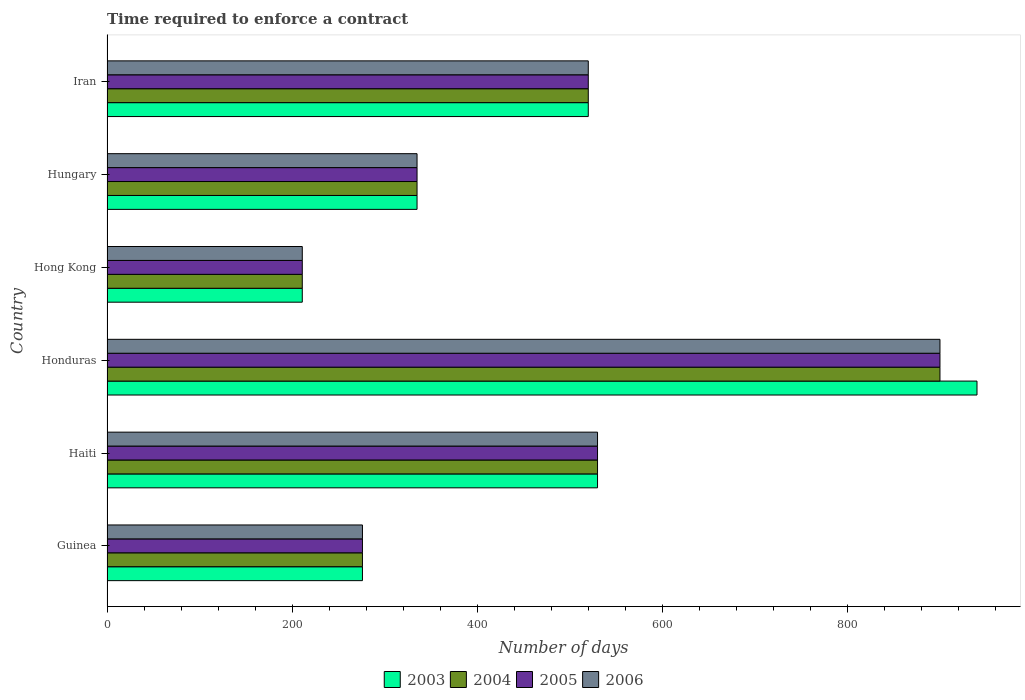How many different coloured bars are there?
Keep it short and to the point. 4. How many groups of bars are there?
Offer a very short reply. 6. Are the number of bars per tick equal to the number of legend labels?
Keep it short and to the point. Yes. What is the label of the 4th group of bars from the top?
Ensure brevity in your answer.  Honduras. In how many cases, is the number of bars for a given country not equal to the number of legend labels?
Keep it short and to the point. 0. What is the number of days required to enforce a contract in 2004 in Guinea?
Offer a very short reply. 276. Across all countries, what is the maximum number of days required to enforce a contract in 2006?
Keep it short and to the point. 900. Across all countries, what is the minimum number of days required to enforce a contract in 2005?
Offer a very short reply. 211. In which country was the number of days required to enforce a contract in 2003 maximum?
Make the answer very short. Honduras. In which country was the number of days required to enforce a contract in 2004 minimum?
Make the answer very short. Hong Kong. What is the total number of days required to enforce a contract in 2005 in the graph?
Provide a short and direct response. 2772. What is the difference between the number of days required to enforce a contract in 2003 in Haiti and that in Honduras?
Provide a succinct answer. -410. What is the difference between the number of days required to enforce a contract in 2003 in Honduras and the number of days required to enforce a contract in 2005 in Hong Kong?
Your answer should be very brief. 729. What is the average number of days required to enforce a contract in 2004 per country?
Make the answer very short. 462. In how many countries, is the number of days required to enforce a contract in 2003 greater than 40 days?
Your answer should be very brief. 6. What is the ratio of the number of days required to enforce a contract in 2005 in Hong Kong to that in Hungary?
Provide a succinct answer. 0.63. Is the number of days required to enforce a contract in 2005 in Honduras less than that in Iran?
Your answer should be compact. No. What is the difference between the highest and the second highest number of days required to enforce a contract in 2005?
Make the answer very short. 370. What is the difference between the highest and the lowest number of days required to enforce a contract in 2006?
Your answer should be very brief. 689. In how many countries, is the number of days required to enforce a contract in 2004 greater than the average number of days required to enforce a contract in 2004 taken over all countries?
Ensure brevity in your answer.  3. Is the sum of the number of days required to enforce a contract in 2004 in Guinea and Honduras greater than the maximum number of days required to enforce a contract in 2005 across all countries?
Your response must be concise. Yes. Is it the case that in every country, the sum of the number of days required to enforce a contract in 2006 and number of days required to enforce a contract in 2003 is greater than the sum of number of days required to enforce a contract in 2004 and number of days required to enforce a contract in 2005?
Ensure brevity in your answer.  No. Is it the case that in every country, the sum of the number of days required to enforce a contract in 2005 and number of days required to enforce a contract in 2004 is greater than the number of days required to enforce a contract in 2003?
Keep it short and to the point. Yes. Are all the bars in the graph horizontal?
Provide a succinct answer. Yes. Are the values on the major ticks of X-axis written in scientific E-notation?
Your answer should be very brief. No. How many legend labels are there?
Offer a very short reply. 4. How are the legend labels stacked?
Your answer should be compact. Horizontal. What is the title of the graph?
Ensure brevity in your answer.  Time required to enforce a contract. Does "1999" appear as one of the legend labels in the graph?
Ensure brevity in your answer.  No. What is the label or title of the X-axis?
Offer a terse response. Number of days. What is the Number of days of 2003 in Guinea?
Make the answer very short. 276. What is the Number of days in 2004 in Guinea?
Your answer should be very brief. 276. What is the Number of days of 2005 in Guinea?
Your response must be concise. 276. What is the Number of days of 2006 in Guinea?
Offer a very short reply. 276. What is the Number of days in 2003 in Haiti?
Your answer should be compact. 530. What is the Number of days of 2004 in Haiti?
Make the answer very short. 530. What is the Number of days of 2005 in Haiti?
Ensure brevity in your answer.  530. What is the Number of days of 2006 in Haiti?
Keep it short and to the point. 530. What is the Number of days of 2003 in Honduras?
Your response must be concise. 940. What is the Number of days of 2004 in Honduras?
Provide a succinct answer. 900. What is the Number of days in 2005 in Honduras?
Keep it short and to the point. 900. What is the Number of days in 2006 in Honduras?
Provide a succinct answer. 900. What is the Number of days in 2003 in Hong Kong?
Keep it short and to the point. 211. What is the Number of days of 2004 in Hong Kong?
Your response must be concise. 211. What is the Number of days of 2005 in Hong Kong?
Your response must be concise. 211. What is the Number of days of 2006 in Hong Kong?
Provide a short and direct response. 211. What is the Number of days of 2003 in Hungary?
Your response must be concise. 335. What is the Number of days of 2004 in Hungary?
Provide a short and direct response. 335. What is the Number of days in 2005 in Hungary?
Make the answer very short. 335. What is the Number of days in 2006 in Hungary?
Give a very brief answer. 335. What is the Number of days in 2003 in Iran?
Ensure brevity in your answer.  520. What is the Number of days of 2004 in Iran?
Keep it short and to the point. 520. What is the Number of days of 2005 in Iran?
Your answer should be compact. 520. What is the Number of days in 2006 in Iran?
Provide a short and direct response. 520. Across all countries, what is the maximum Number of days in 2003?
Your response must be concise. 940. Across all countries, what is the maximum Number of days of 2004?
Give a very brief answer. 900. Across all countries, what is the maximum Number of days of 2005?
Offer a very short reply. 900. Across all countries, what is the maximum Number of days of 2006?
Give a very brief answer. 900. Across all countries, what is the minimum Number of days in 2003?
Provide a succinct answer. 211. Across all countries, what is the minimum Number of days in 2004?
Ensure brevity in your answer.  211. Across all countries, what is the minimum Number of days of 2005?
Offer a terse response. 211. Across all countries, what is the minimum Number of days of 2006?
Offer a terse response. 211. What is the total Number of days in 2003 in the graph?
Make the answer very short. 2812. What is the total Number of days of 2004 in the graph?
Offer a terse response. 2772. What is the total Number of days of 2005 in the graph?
Your answer should be very brief. 2772. What is the total Number of days of 2006 in the graph?
Your answer should be very brief. 2772. What is the difference between the Number of days in 2003 in Guinea and that in Haiti?
Your answer should be very brief. -254. What is the difference between the Number of days in 2004 in Guinea and that in Haiti?
Offer a terse response. -254. What is the difference between the Number of days of 2005 in Guinea and that in Haiti?
Make the answer very short. -254. What is the difference between the Number of days in 2006 in Guinea and that in Haiti?
Keep it short and to the point. -254. What is the difference between the Number of days of 2003 in Guinea and that in Honduras?
Ensure brevity in your answer.  -664. What is the difference between the Number of days in 2004 in Guinea and that in Honduras?
Your answer should be compact. -624. What is the difference between the Number of days in 2005 in Guinea and that in Honduras?
Make the answer very short. -624. What is the difference between the Number of days in 2006 in Guinea and that in Honduras?
Keep it short and to the point. -624. What is the difference between the Number of days in 2003 in Guinea and that in Hong Kong?
Make the answer very short. 65. What is the difference between the Number of days of 2004 in Guinea and that in Hong Kong?
Offer a very short reply. 65. What is the difference between the Number of days of 2005 in Guinea and that in Hong Kong?
Ensure brevity in your answer.  65. What is the difference between the Number of days in 2006 in Guinea and that in Hong Kong?
Give a very brief answer. 65. What is the difference between the Number of days of 2003 in Guinea and that in Hungary?
Give a very brief answer. -59. What is the difference between the Number of days of 2004 in Guinea and that in Hungary?
Keep it short and to the point. -59. What is the difference between the Number of days of 2005 in Guinea and that in Hungary?
Your response must be concise. -59. What is the difference between the Number of days in 2006 in Guinea and that in Hungary?
Your response must be concise. -59. What is the difference between the Number of days of 2003 in Guinea and that in Iran?
Make the answer very short. -244. What is the difference between the Number of days of 2004 in Guinea and that in Iran?
Offer a terse response. -244. What is the difference between the Number of days in 2005 in Guinea and that in Iran?
Provide a succinct answer. -244. What is the difference between the Number of days of 2006 in Guinea and that in Iran?
Keep it short and to the point. -244. What is the difference between the Number of days of 2003 in Haiti and that in Honduras?
Your answer should be very brief. -410. What is the difference between the Number of days of 2004 in Haiti and that in Honduras?
Provide a succinct answer. -370. What is the difference between the Number of days in 2005 in Haiti and that in Honduras?
Provide a short and direct response. -370. What is the difference between the Number of days in 2006 in Haiti and that in Honduras?
Keep it short and to the point. -370. What is the difference between the Number of days of 2003 in Haiti and that in Hong Kong?
Your response must be concise. 319. What is the difference between the Number of days of 2004 in Haiti and that in Hong Kong?
Your response must be concise. 319. What is the difference between the Number of days of 2005 in Haiti and that in Hong Kong?
Your answer should be compact. 319. What is the difference between the Number of days in 2006 in Haiti and that in Hong Kong?
Ensure brevity in your answer.  319. What is the difference between the Number of days in 2003 in Haiti and that in Hungary?
Your response must be concise. 195. What is the difference between the Number of days in 2004 in Haiti and that in Hungary?
Provide a short and direct response. 195. What is the difference between the Number of days in 2005 in Haiti and that in Hungary?
Provide a short and direct response. 195. What is the difference between the Number of days in 2006 in Haiti and that in Hungary?
Your answer should be compact. 195. What is the difference between the Number of days in 2003 in Haiti and that in Iran?
Give a very brief answer. 10. What is the difference between the Number of days of 2004 in Haiti and that in Iran?
Offer a terse response. 10. What is the difference between the Number of days of 2003 in Honduras and that in Hong Kong?
Give a very brief answer. 729. What is the difference between the Number of days in 2004 in Honduras and that in Hong Kong?
Your response must be concise. 689. What is the difference between the Number of days of 2005 in Honduras and that in Hong Kong?
Give a very brief answer. 689. What is the difference between the Number of days of 2006 in Honduras and that in Hong Kong?
Offer a very short reply. 689. What is the difference between the Number of days of 2003 in Honduras and that in Hungary?
Ensure brevity in your answer.  605. What is the difference between the Number of days of 2004 in Honduras and that in Hungary?
Provide a short and direct response. 565. What is the difference between the Number of days of 2005 in Honduras and that in Hungary?
Give a very brief answer. 565. What is the difference between the Number of days of 2006 in Honduras and that in Hungary?
Ensure brevity in your answer.  565. What is the difference between the Number of days of 2003 in Honduras and that in Iran?
Ensure brevity in your answer.  420. What is the difference between the Number of days of 2004 in Honduras and that in Iran?
Offer a terse response. 380. What is the difference between the Number of days in 2005 in Honduras and that in Iran?
Keep it short and to the point. 380. What is the difference between the Number of days of 2006 in Honduras and that in Iran?
Keep it short and to the point. 380. What is the difference between the Number of days in 2003 in Hong Kong and that in Hungary?
Keep it short and to the point. -124. What is the difference between the Number of days of 2004 in Hong Kong and that in Hungary?
Make the answer very short. -124. What is the difference between the Number of days of 2005 in Hong Kong and that in Hungary?
Ensure brevity in your answer.  -124. What is the difference between the Number of days of 2006 in Hong Kong and that in Hungary?
Offer a terse response. -124. What is the difference between the Number of days of 2003 in Hong Kong and that in Iran?
Offer a terse response. -309. What is the difference between the Number of days in 2004 in Hong Kong and that in Iran?
Give a very brief answer. -309. What is the difference between the Number of days in 2005 in Hong Kong and that in Iran?
Your response must be concise. -309. What is the difference between the Number of days in 2006 in Hong Kong and that in Iran?
Your answer should be very brief. -309. What is the difference between the Number of days in 2003 in Hungary and that in Iran?
Your response must be concise. -185. What is the difference between the Number of days in 2004 in Hungary and that in Iran?
Provide a short and direct response. -185. What is the difference between the Number of days in 2005 in Hungary and that in Iran?
Your response must be concise. -185. What is the difference between the Number of days in 2006 in Hungary and that in Iran?
Your answer should be very brief. -185. What is the difference between the Number of days in 2003 in Guinea and the Number of days in 2004 in Haiti?
Offer a terse response. -254. What is the difference between the Number of days in 2003 in Guinea and the Number of days in 2005 in Haiti?
Your answer should be compact. -254. What is the difference between the Number of days in 2003 in Guinea and the Number of days in 2006 in Haiti?
Your response must be concise. -254. What is the difference between the Number of days in 2004 in Guinea and the Number of days in 2005 in Haiti?
Offer a terse response. -254. What is the difference between the Number of days of 2004 in Guinea and the Number of days of 2006 in Haiti?
Give a very brief answer. -254. What is the difference between the Number of days of 2005 in Guinea and the Number of days of 2006 in Haiti?
Provide a short and direct response. -254. What is the difference between the Number of days in 2003 in Guinea and the Number of days in 2004 in Honduras?
Keep it short and to the point. -624. What is the difference between the Number of days in 2003 in Guinea and the Number of days in 2005 in Honduras?
Ensure brevity in your answer.  -624. What is the difference between the Number of days in 2003 in Guinea and the Number of days in 2006 in Honduras?
Offer a terse response. -624. What is the difference between the Number of days of 2004 in Guinea and the Number of days of 2005 in Honduras?
Provide a short and direct response. -624. What is the difference between the Number of days in 2004 in Guinea and the Number of days in 2006 in Honduras?
Your answer should be very brief. -624. What is the difference between the Number of days in 2005 in Guinea and the Number of days in 2006 in Honduras?
Offer a terse response. -624. What is the difference between the Number of days in 2003 in Guinea and the Number of days in 2005 in Hong Kong?
Your answer should be compact. 65. What is the difference between the Number of days of 2004 in Guinea and the Number of days of 2005 in Hong Kong?
Provide a short and direct response. 65. What is the difference between the Number of days in 2004 in Guinea and the Number of days in 2006 in Hong Kong?
Ensure brevity in your answer.  65. What is the difference between the Number of days of 2005 in Guinea and the Number of days of 2006 in Hong Kong?
Offer a very short reply. 65. What is the difference between the Number of days of 2003 in Guinea and the Number of days of 2004 in Hungary?
Provide a succinct answer. -59. What is the difference between the Number of days in 2003 in Guinea and the Number of days in 2005 in Hungary?
Keep it short and to the point. -59. What is the difference between the Number of days of 2003 in Guinea and the Number of days of 2006 in Hungary?
Provide a succinct answer. -59. What is the difference between the Number of days of 2004 in Guinea and the Number of days of 2005 in Hungary?
Make the answer very short. -59. What is the difference between the Number of days in 2004 in Guinea and the Number of days in 2006 in Hungary?
Make the answer very short. -59. What is the difference between the Number of days of 2005 in Guinea and the Number of days of 2006 in Hungary?
Offer a terse response. -59. What is the difference between the Number of days in 2003 in Guinea and the Number of days in 2004 in Iran?
Ensure brevity in your answer.  -244. What is the difference between the Number of days of 2003 in Guinea and the Number of days of 2005 in Iran?
Your answer should be very brief. -244. What is the difference between the Number of days in 2003 in Guinea and the Number of days in 2006 in Iran?
Provide a succinct answer. -244. What is the difference between the Number of days in 2004 in Guinea and the Number of days in 2005 in Iran?
Provide a succinct answer. -244. What is the difference between the Number of days of 2004 in Guinea and the Number of days of 2006 in Iran?
Make the answer very short. -244. What is the difference between the Number of days in 2005 in Guinea and the Number of days in 2006 in Iran?
Offer a terse response. -244. What is the difference between the Number of days in 2003 in Haiti and the Number of days in 2004 in Honduras?
Your response must be concise. -370. What is the difference between the Number of days in 2003 in Haiti and the Number of days in 2005 in Honduras?
Your response must be concise. -370. What is the difference between the Number of days of 2003 in Haiti and the Number of days of 2006 in Honduras?
Provide a short and direct response. -370. What is the difference between the Number of days in 2004 in Haiti and the Number of days in 2005 in Honduras?
Offer a very short reply. -370. What is the difference between the Number of days of 2004 in Haiti and the Number of days of 2006 in Honduras?
Offer a terse response. -370. What is the difference between the Number of days of 2005 in Haiti and the Number of days of 2006 in Honduras?
Your answer should be very brief. -370. What is the difference between the Number of days in 2003 in Haiti and the Number of days in 2004 in Hong Kong?
Offer a terse response. 319. What is the difference between the Number of days of 2003 in Haiti and the Number of days of 2005 in Hong Kong?
Your response must be concise. 319. What is the difference between the Number of days of 2003 in Haiti and the Number of days of 2006 in Hong Kong?
Offer a terse response. 319. What is the difference between the Number of days in 2004 in Haiti and the Number of days in 2005 in Hong Kong?
Make the answer very short. 319. What is the difference between the Number of days of 2004 in Haiti and the Number of days of 2006 in Hong Kong?
Keep it short and to the point. 319. What is the difference between the Number of days of 2005 in Haiti and the Number of days of 2006 in Hong Kong?
Provide a succinct answer. 319. What is the difference between the Number of days in 2003 in Haiti and the Number of days in 2004 in Hungary?
Your answer should be very brief. 195. What is the difference between the Number of days of 2003 in Haiti and the Number of days of 2005 in Hungary?
Provide a short and direct response. 195. What is the difference between the Number of days in 2003 in Haiti and the Number of days in 2006 in Hungary?
Offer a very short reply. 195. What is the difference between the Number of days in 2004 in Haiti and the Number of days in 2005 in Hungary?
Your answer should be very brief. 195. What is the difference between the Number of days in 2004 in Haiti and the Number of days in 2006 in Hungary?
Ensure brevity in your answer.  195. What is the difference between the Number of days in 2005 in Haiti and the Number of days in 2006 in Hungary?
Offer a terse response. 195. What is the difference between the Number of days of 2003 in Haiti and the Number of days of 2004 in Iran?
Provide a short and direct response. 10. What is the difference between the Number of days in 2003 in Haiti and the Number of days in 2005 in Iran?
Offer a terse response. 10. What is the difference between the Number of days in 2003 in Haiti and the Number of days in 2006 in Iran?
Keep it short and to the point. 10. What is the difference between the Number of days in 2004 in Haiti and the Number of days in 2005 in Iran?
Offer a very short reply. 10. What is the difference between the Number of days of 2004 in Haiti and the Number of days of 2006 in Iran?
Your response must be concise. 10. What is the difference between the Number of days in 2005 in Haiti and the Number of days in 2006 in Iran?
Make the answer very short. 10. What is the difference between the Number of days of 2003 in Honduras and the Number of days of 2004 in Hong Kong?
Provide a succinct answer. 729. What is the difference between the Number of days in 2003 in Honduras and the Number of days in 2005 in Hong Kong?
Keep it short and to the point. 729. What is the difference between the Number of days in 2003 in Honduras and the Number of days in 2006 in Hong Kong?
Your response must be concise. 729. What is the difference between the Number of days of 2004 in Honduras and the Number of days of 2005 in Hong Kong?
Keep it short and to the point. 689. What is the difference between the Number of days of 2004 in Honduras and the Number of days of 2006 in Hong Kong?
Your answer should be very brief. 689. What is the difference between the Number of days in 2005 in Honduras and the Number of days in 2006 in Hong Kong?
Your answer should be very brief. 689. What is the difference between the Number of days in 2003 in Honduras and the Number of days in 2004 in Hungary?
Your response must be concise. 605. What is the difference between the Number of days of 2003 in Honduras and the Number of days of 2005 in Hungary?
Give a very brief answer. 605. What is the difference between the Number of days in 2003 in Honduras and the Number of days in 2006 in Hungary?
Offer a terse response. 605. What is the difference between the Number of days in 2004 in Honduras and the Number of days in 2005 in Hungary?
Offer a very short reply. 565. What is the difference between the Number of days in 2004 in Honduras and the Number of days in 2006 in Hungary?
Provide a succinct answer. 565. What is the difference between the Number of days of 2005 in Honduras and the Number of days of 2006 in Hungary?
Make the answer very short. 565. What is the difference between the Number of days of 2003 in Honduras and the Number of days of 2004 in Iran?
Ensure brevity in your answer.  420. What is the difference between the Number of days of 2003 in Honduras and the Number of days of 2005 in Iran?
Make the answer very short. 420. What is the difference between the Number of days in 2003 in Honduras and the Number of days in 2006 in Iran?
Provide a succinct answer. 420. What is the difference between the Number of days in 2004 in Honduras and the Number of days in 2005 in Iran?
Your answer should be compact. 380. What is the difference between the Number of days of 2004 in Honduras and the Number of days of 2006 in Iran?
Offer a very short reply. 380. What is the difference between the Number of days of 2005 in Honduras and the Number of days of 2006 in Iran?
Give a very brief answer. 380. What is the difference between the Number of days in 2003 in Hong Kong and the Number of days in 2004 in Hungary?
Your response must be concise. -124. What is the difference between the Number of days in 2003 in Hong Kong and the Number of days in 2005 in Hungary?
Keep it short and to the point. -124. What is the difference between the Number of days of 2003 in Hong Kong and the Number of days of 2006 in Hungary?
Make the answer very short. -124. What is the difference between the Number of days of 2004 in Hong Kong and the Number of days of 2005 in Hungary?
Offer a terse response. -124. What is the difference between the Number of days of 2004 in Hong Kong and the Number of days of 2006 in Hungary?
Offer a terse response. -124. What is the difference between the Number of days in 2005 in Hong Kong and the Number of days in 2006 in Hungary?
Make the answer very short. -124. What is the difference between the Number of days in 2003 in Hong Kong and the Number of days in 2004 in Iran?
Your response must be concise. -309. What is the difference between the Number of days in 2003 in Hong Kong and the Number of days in 2005 in Iran?
Provide a short and direct response. -309. What is the difference between the Number of days of 2003 in Hong Kong and the Number of days of 2006 in Iran?
Offer a terse response. -309. What is the difference between the Number of days in 2004 in Hong Kong and the Number of days in 2005 in Iran?
Ensure brevity in your answer.  -309. What is the difference between the Number of days of 2004 in Hong Kong and the Number of days of 2006 in Iran?
Provide a succinct answer. -309. What is the difference between the Number of days of 2005 in Hong Kong and the Number of days of 2006 in Iran?
Give a very brief answer. -309. What is the difference between the Number of days in 2003 in Hungary and the Number of days in 2004 in Iran?
Give a very brief answer. -185. What is the difference between the Number of days of 2003 in Hungary and the Number of days of 2005 in Iran?
Ensure brevity in your answer.  -185. What is the difference between the Number of days in 2003 in Hungary and the Number of days in 2006 in Iran?
Give a very brief answer. -185. What is the difference between the Number of days in 2004 in Hungary and the Number of days in 2005 in Iran?
Offer a very short reply. -185. What is the difference between the Number of days of 2004 in Hungary and the Number of days of 2006 in Iran?
Keep it short and to the point. -185. What is the difference between the Number of days in 2005 in Hungary and the Number of days in 2006 in Iran?
Offer a very short reply. -185. What is the average Number of days of 2003 per country?
Make the answer very short. 468.67. What is the average Number of days of 2004 per country?
Give a very brief answer. 462. What is the average Number of days in 2005 per country?
Provide a short and direct response. 462. What is the average Number of days of 2006 per country?
Offer a terse response. 462. What is the difference between the Number of days in 2003 and Number of days in 2004 in Guinea?
Provide a succinct answer. 0. What is the difference between the Number of days of 2003 and Number of days of 2006 in Guinea?
Offer a terse response. 0. What is the difference between the Number of days in 2003 and Number of days in 2004 in Haiti?
Provide a succinct answer. 0. What is the difference between the Number of days in 2004 and Number of days in 2005 in Haiti?
Your answer should be compact. 0. What is the difference between the Number of days in 2004 and Number of days in 2006 in Haiti?
Offer a terse response. 0. What is the difference between the Number of days in 2005 and Number of days in 2006 in Haiti?
Your response must be concise. 0. What is the difference between the Number of days in 2003 and Number of days in 2005 in Honduras?
Ensure brevity in your answer.  40. What is the difference between the Number of days in 2004 and Number of days in 2005 in Honduras?
Make the answer very short. 0. What is the difference between the Number of days in 2005 and Number of days in 2006 in Honduras?
Give a very brief answer. 0. What is the difference between the Number of days of 2003 and Number of days of 2006 in Hong Kong?
Your answer should be compact. 0. What is the difference between the Number of days of 2004 and Number of days of 2006 in Hong Kong?
Your answer should be very brief. 0. What is the difference between the Number of days in 2005 and Number of days in 2006 in Hong Kong?
Ensure brevity in your answer.  0. What is the difference between the Number of days in 2003 and Number of days in 2006 in Hungary?
Provide a succinct answer. 0. What is the difference between the Number of days in 2004 and Number of days in 2005 in Hungary?
Your response must be concise. 0. What is the difference between the Number of days of 2004 and Number of days of 2006 in Hungary?
Ensure brevity in your answer.  0. What is the difference between the Number of days of 2005 and Number of days of 2006 in Hungary?
Offer a terse response. 0. What is the difference between the Number of days of 2003 and Number of days of 2005 in Iran?
Offer a terse response. 0. What is the ratio of the Number of days in 2003 in Guinea to that in Haiti?
Your answer should be compact. 0.52. What is the ratio of the Number of days of 2004 in Guinea to that in Haiti?
Provide a short and direct response. 0.52. What is the ratio of the Number of days in 2005 in Guinea to that in Haiti?
Keep it short and to the point. 0.52. What is the ratio of the Number of days in 2006 in Guinea to that in Haiti?
Provide a succinct answer. 0.52. What is the ratio of the Number of days of 2003 in Guinea to that in Honduras?
Provide a short and direct response. 0.29. What is the ratio of the Number of days in 2004 in Guinea to that in Honduras?
Offer a terse response. 0.31. What is the ratio of the Number of days in 2005 in Guinea to that in Honduras?
Your answer should be compact. 0.31. What is the ratio of the Number of days in 2006 in Guinea to that in Honduras?
Keep it short and to the point. 0.31. What is the ratio of the Number of days in 2003 in Guinea to that in Hong Kong?
Your answer should be very brief. 1.31. What is the ratio of the Number of days of 2004 in Guinea to that in Hong Kong?
Ensure brevity in your answer.  1.31. What is the ratio of the Number of days of 2005 in Guinea to that in Hong Kong?
Ensure brevity in your answer.  1.31. What is the ratio of the Number of days of 2006 in Guinea to that in Hong Kong?
Your answer should be very brief. 1.31. What is the ratio of the Number of days of 2003 in Guinea to that in Hungary?
Your response must be concise. 0.82. What is the ratio of the Number of days in 2004 in Guinea to that in Hungary?
Your answer should be compact. 0.82. What is the ratio of the Number of days in 2005 in Guinea to that in Hungary?
Offer a terse response. 0.82. What is the ratio of the Number of days of 2006 in Guinea to that in Hungary?
Give a very brief answer. 0.82. What is the ratio of the Number of days in 2003 in Guinea to that in Iran?
Provide a succinct answer. 0.53. What is the ratio of the Number of days in 2004 in Guinea to that in Iran?
Your response must be concise. 0.53. What is the ratio of the Number of days of 2005 in Guinea to that in Iran?
Give a very brief answer. 0.53. What is the ratio of the Number of days in 2006 in Guinea to that in Iran?
Your answer should be very brief. 0.53. What is the ratio of the Number of days in 2003 in Haiti to that in Honduras?
Give a very brief answer. 0.56. What is the ratio of the Number of days of 2004 in Haiti to that in Honduras?
Give a very brief answer. 0.59. What is the ratio of the Number of days in 2005 in Haiti to that in Honduras?
Offer a very short reply. 0.59. What is the ratio of the Number of days in 2006 in Haiti to that in Honduras?
Your response must be concise. 0.59. What is the ratio of the Number of days in 2003 in Haiti to that in Hong Kong?
Your answer should be compact. 2.51. What is the ratio of the Number of days in 2004 in Haiti to that in Hong Kong?
Give a very brief answer. 2.51. What is the ratio of the Number of days of 2005 in Haiti to that in Hong Kong?
Offer a very short reply. 2.51. What is the ratio of the Number of days of 2006 in Haiti to that in Hong Kong?
Ensure brevity in your answer.  2.51. What is the ratio of the Number of days in 2003 in Haiti to that in Hungary?
Make the answer very short. 1.58. What is the ratio of the Number of days of 2004 in Haiti to that in Hungary?
Ensure brevity in your answer.  1.58. What is the ratio of the Number of days of 2005 in Haiti to that in Hungary?
Your response must be concise. 1.58. What is the ratio of the Number of days in 2006 in Haiti to that in Hungary?
Your answer should be very brief. 1.58. What is the ratio of the Number of days of 2003 in Haiti to that in Iran?
Your answer should be very brief. 1.02. What is the ratio of the Number of days in 2004 in Haiti to that in Iran?
Provide a succinct answer. 1.02. What is the ratio of the Number of days of 2005 in Haiti to that in Iran?
Keep it short and to the point. 1.02. What is the ratio of the Number of days in 2006 in Haiti to that in Iran?
Ensure brevity in your answer.  1.02. What is the ratio of the Number of days in 2003 in Honduras to that in Hong Kong?
Provide a short and direct response. 4.46. What is the ratio of the Number of days of 2004 in Honduras to that in Hong Kong?
Make the answer very short. 4.27. What is the ratio of the Number of days in 2005 in Honduras to that in Hong Kong?
Your answer should be very brief. 4.27. What is the ratio of the Number of days of 2006 in Honduras to that in Hong Kong?
Your answer should be very brief. 4.27. What is the ratio of the Number of days of 2003 in Honduras to that in Hungary?
Provide a short and direct response. 2.81. What is the ratio of the Number of days in 2004 in Honduras to that in Hungary?
Make the answer very short. 2.69. What is the ratio of the Number of days in 2005 in Honduras to that in Hungary?
Give a very brief answer. 2.69. What is the ratio of the Number of days in 2006 in Honduras to that in Hungary?
Your response must be concise. 2.69. What is the ratio of the Number of days in 2003 in Honduras to that in Iran?
Ensure brevity in your answer.  1.81. What is the ratio of the Number of days in 2004 in Honduras to that in Iran?
Offer a terse response. 1.73. What is the ratio of the Number of days of 2005 in Honduras to that in Iran?
Keep it short and to the point. 1.73. What is the ratio of the Number of days of 2006 in Honduras to that in Iran?
Offer a very short reply. 1.73. What is the ratio of the Number of days in 2003 in Hong Kong to that in Hungary?
Provide a short and direct response. 0.63. What is the ratio of the Number of days of 2004 in Hong Kong to that in Hungary?
Ensure brevity in your answer.  0.63. What is the ratio of the Number of days in 2005 in Hong Kong to that in Hungary?
Keep it short and to the point. 0.63. What is the ratio of the Number of days in 2006 in Hong Kong to that in Hungary?
Ensure brevity in your answer.  0.63. What is the ratio of the Number of days of 2003 in Hong Kong to that in Iran?
Your answer should be compact. 0.41. What is the ratio of the Number of days in 2004 in Hong Kong to that in Iran?
Provide a succinct answer. 0.41. What is the ratio of the Number of days in 2005 in Hong Kong to that in Iran?
Make the answer very short. 0.41. What is the ratio of the Number of days in 2006 in Hong Kong to that in Iran?
Provide a short and direct response. 0.41. What is the ratio of the Number of days in 2003 in Hungary to that in Iran?
Your answer should be very brief. 0.64. What is the ratio of the Number of days in 2004 in Hungary to that in Iran?
Your answer should be compact. 0.64. What is the ratio of the Number of days of 2005 in Hungary to that in Iran?
Offer a very short reply. 0.64. What is the ratio of the Number of days in 2006 in Hungary to that in Iran?
Your response must be concise. 0.64. What is the difference between the highest and the second highest Number of days of 2003?
Make the answer very short. 410. What is the difference between the highest and the second highest Number of days in 2004?
Your answer should be compact. 370. What is the difference between the highest and the second highest Number of days in 2005?
Your response must be concise. 370. What is the difference between the highest and the second highest Number of days of 2006?
Offer a terse response. 370. What is the difference between the highest and the lowest Number of days of 2003?
Keep it short and to the point. 729. What is the difference between the highest and the lowest Number of days of 2004?
Give a very brief answer. 689. What is the difference between the highest and the lowest Number of days in 2005?
Ensure brevity in your answer.  689. What is the difference between the highest and the lowest Number of days in 2006?
Your answer should be compact. 689. 